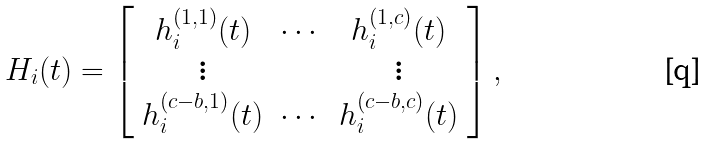<formula> <loc_0><loc_0><loc_500><loc_500>H _ { i } ( t ) = \left [ \begin{array} { c c c } h _ { i } ^ { ( 1 , 1 ) } ( t ) & \cdots & h _ { i } ^ { ( 1 , c ) } ( t ) \\ \vdots & & \vdots \\ h _ { i } ^ { ( c - b , 1 ) } ( t ) & \cdots & h _ { i } ^ { ( c - b , c ) } ( t ) \\ \end{array} \right ] ,</formula> 